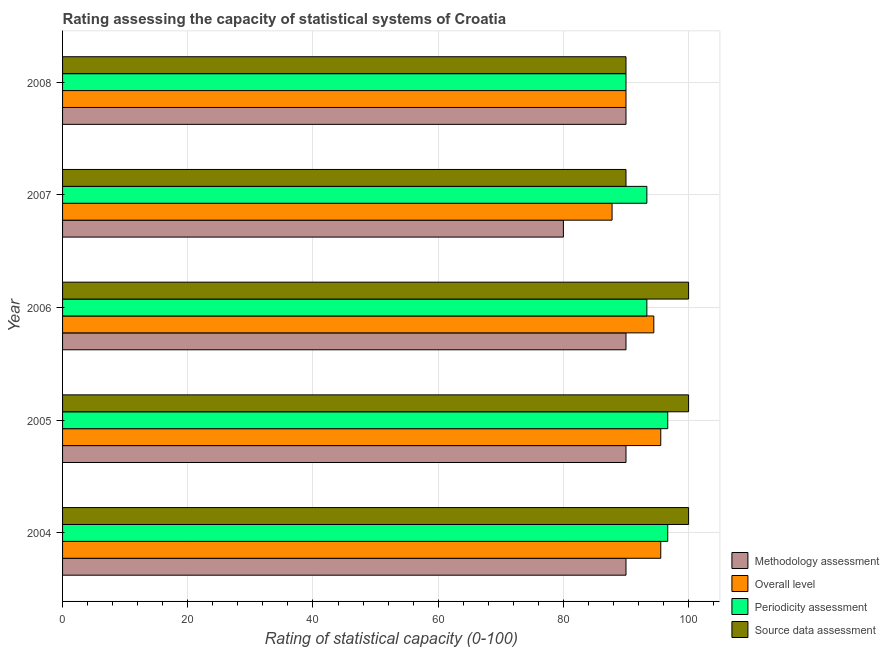How many different coloured bars are there?
Provide a short and direct response. 4. How many groups of bars are there?
Your answer should be compact. 5. Are the number of bars on each tick of the Y-axis equal?
Provide a succinct answer. Yes. What is the label of the 5th group of bars from the top?
Offer a very short reply. 2004. In how many cases, is the number of bars for a given year not equal to the number of legend labels?
Offer a terse response. 0. What is the methodology assessment rating in 2004?
Your response must be concise. 90. Across all years, what is the maximum periodicity assessment rating?
Make the answer very short. 96.67. Across all years, what is the minimum overall level rating?
Ensure brevity in your answer.  87.78. In which year was the source data assessment rating maximum?
Provide a short and direct response. 2004. In which year was the periodicity assessment rating minimum?
Offer a terse response. 2008. What is the total overall level rating in the graph?
Keep it short and to the point. 463.33. What is the difference between the source data assessment rating in 2005 and that in 2007?
Provide a succinct answer. 10. What is the difference between the periodicity assessment rating in 2005 and the source data assessment rating in 2007?
Make the answer very short. 6.67. What is the average methodology assessment rating per year?
Offer a terse response. 88. In the year 2005, what is the difference between the methodology assessment rating and overall level rating?
Your response must be concise. -5.56. In how many years, is the overall level rating greater than 4 ?
Ensure brevity in your answer.  5. What is the ratio of the source data assessment rating in 2004 to that in 2008?
Your response must be concise. 1.11. Is the periodicity assessment rating in 2004 less than that in 2007?
Your response must be concise. No. What is the difference between the highest and the second highest periodicity assessment rating?
Ensure brevity in your answer.  0. What is the difference between the highest and the lowest source data assessment rating?
Make the answer very short. 10. In how many years, is the source data assessment rating greater than the average source data assessment rating taken over all years?
Your response must be concise. 3. Is it the case that in every year, the sum of the periodicity assessment rating and source data assessment rating is greater than the sum of overall level rating and methodology assessment rating?
Offer a very short reply. Yes. What does the 3rd bar from the top in 2004 represents?
Keep it short and to the point. Overall level. What does the 2nd bar from the bottom in 2007 represents?
Your answer should be compact. Overall level. How many years are there in the graph?
Provide a short and direct response. 5. Are the values on the major ticks of X-axis written in scientific E-notation?
Provide a short and direct response. No. Does the graph contain any zero values?
Your response must be concise. No. How many legend labels are there?
Offer a terse response. 4. What is the title of the graph?
Your answer should be compact. Rating assessing the capacity of statistical systems of Croatia. Does "Manufacturing" appear as one of the legend labels in the graph?
Make the answer very short. No. What is the label or title of the X-axis?
Your answer should be very brief. Rating of statistical capacity (0-100). What is the Rating of statistical capacity (0-100) of Methodology assessment in 2004?
Your response must be concise. 90. What is the Rating of statistical capacity (0-100) of Overall level in 2004?
Offer a very short reply. 95.56. What is the Rating of statistical capacity (0-100) in Periodicity assessment in 2004?
Make the answer very short. 96.67. What is the Rating of statistical capacity (0-100) in Source data assessment in 2004?
Provide a short and direct response. 100. What is the Rating of statistical capacity (0-100) of Methodology assessment in 2005?
Offer a very short reply. 90. What is the Rating of statistical capacity (0-100) in Overall level in 2005?
Keep it short and to the point. 95.56. What is the Rating of statistical capacity (0-100) of Periodicity assessment in 2005?
Offer a terse response. 96.67. What is the Rating of statistical capacity (0-100) of Source data assessment in 2005?
Make the answer very short. 100. What is the Rating of statistical capacity (0-100) of Overall level in 2006?
Ensure brevity in your answer.  94.44. What is the Rating of statistical capacity (0-100) of Periodicity assessment in 2006?
Your answer should be compact. 93.33. What is the Rating of statistical capacity (0-100) in Methodology assessment in 2007?
Your answer should be compact. 80. What is the Rating of statistical capacity (0-100) in Overall level in 2007?
Your answer should be compact. 87.78. What is the Rating of statistical capacity (0-100) in Periodicity assessment in 2007?
Keep it short and to the point. 93.33. What is the Rating of statistical capacity (0-100) of Source data assessment in 2007?
Ensure brevity in your answer.  90. What is the Rating of statistical capacity (0-100) in Source data assessment in 2008?
Your response must be concise. 90. Across all years, what is the maximum Rating of statistical capacity (0-100) of Methodology assessment?
Your response must be concise. 90. Across all years, what is the maximum Rating of statistical capacity (0-100) in Overall level?
Provide a short and direct response. 95.56. Across all years, what is the maximum Rating of statistical capacity (0-100) in Periodicity assessment?
Your answer should be compact. 96.67. Across all years, what is the maximum Rating of statistical capacity (0-100) of Source data assessment?
Your answer should be very brief. 100. Across all years, what is the minimum Rating of statistical capacity (0-100) in Methodology assessment?
Keep it short and to the point. 80. Across all years, what is the minimum Rating of statistical capacity (0-100) in Overall level?
Provide a short and direct response. 87.78. Across all years, what is the minimum Rating of statistical capacity (0-100) of Source data assessment?
Offer a very short reply. 90. What is the total Rating of statistical capacity (0-100) in Methodology assessment in the graph?
Your answer should be compact. 440. What is the total Rating of statistical capacity (0-100) of Overall level in the graph?
Give a very brief answer. 463.33. What is the total Rating of statistical capacity (0-100) in Periodicity assessment in the graph?
Provide a short and direct response. 470. What is the total Rating of statistical capacity (0-100) in Source data assessment in the graph?
Offer a terse response. 480. What is the difference between the Rating of statistical capacity (0-100) in Periodicity assessment in 2004 and that in 2005?
Make the answer very short. 0. What is the difference between the Rating of statistical capacity (0-100) in Source data assessment in 2004 and that in 2005?
Keep it short and to the point. 0. What is the difference between the Rating of statistical capacity (0-100) of Methodology assessment in 2004 and that in 2006?
Your answer should be very brief. 0. What is the difference between the Rating of statistical capacity (0-100) in Overall level in 2004 and that in 2006?
Give a very brief answer. 1.11. What is the difference between the Rating of statistical capacity (0-100) of Periodicity assessment in 2004 and that in 2006?
Your answer should be compact. 3.33. What is the difference between the Rating of statistical capacity (0-100) in Overall level in 2004 and that in 2007?
Offer a terse response. 7.78. What is the difference between the Rating of statistical capacity (0-100) in Periodicity assessment in 2004 and that in 2007?
Ensure brevity in your answer.  3.33. What is the difference between the Rating of statistical capacity (0-100) in Methodology assessment in 2004 and that in 2008?
Your response must be concise. 0. What is the difference between the Rating of statistical capacity (0-100) of Overall level in 2004 and that in 2008?
Provide a short and direct response. 5.56. What is the difference between the Rating of statistical capacity (0-100) in Periodicity assessment in 2004 and that in 2008?
Your answer should be compact. 6.67. What is the difference between the Rating of statistical capacity (0-100) of Methodology assessment in 2005 and that in 2006?
Provide a succinct answer. 0. What is the difference between the Rating of statistical capacity (0-100) in Overall level in 2005 and that in 2006?
Offer a terse response. 1.11. What is the difference between the Rating of statistical capacity (0-100) of Periodicity assessment in 2005 and that in 2006?
Provide a succinct answer. 3.33. What is the difference between the Rating of statistical capacity (0-100) of Overall level in 2005 and that in 2007?
Your answer should be very brief. 7.78. What is the difference between the Rating of statistical capacity (0-100) of Source data assessment in 2005 and that in 2007?
Ensure brevity in your answer.  10. What is the difference between the Rating of statistical capacity (0-100) in Methodology assessment in 2005 and that in 2008?
Your answer should be very brief. 0. What is the difference between the Rating of statistical capacity (0-100) of Overall level in 2005 and that in 2008?
Ensure brevity in your answer.  5.56. What is the difference between the Rating of statistical capacity (0-100) of Periodicity assessment in 2005 and that in 2008?
Give a very brief answer. 6.67. What is the difference between the Rating of statistical capacity (0-100) in Source data assessment in 2005 and that in 2008?
Ensure brevity in your answer.  10. What is the difference between the Rating of statistical capacity (0-100) of Overall level in 2006 and that in 2008?
Offer a very short reply. 4.44. What is the difference between the Rating of statistical capacity (0-100) of Periodicity assessment in 2006 and that in 2008?
Your answer should be compact. 3.33. What is the difference between the Rating of statistical capacity (0-100) of Overall level in 2007 and that in 2008?
Your response must be concise. -2.22. What is the difference between the Rating of statistical capacity (0-100) in Methodology assessment in 2004 and the Rating of statistical capacity (0-100) in Overall level in 2005?
Your answer should be very brief. -5.56. What is the difference between the Rating of statistical capacity (0-100) of Methodology assessment in 2004 and the Rating of statistical capacity (0-100) of Periodicity assessment in 2005?
Keep it short and to the point. -6.67. What is the difference between the Rating of statistical capacity (0-100) in Methodology assessment in 2004 and the Rating of statistical capacity (0-100) in Source data assessment in 2005?
Ensure brevity in your answer.  -10. What is the difference between the Rating of statistical capacity (0-100) in Overall level in 2004 and the Rating of statistical capacity (0-100) in Periodicity assessment in 2005?
Ensure brevity in your answer.  -1.11. What is the difference between the Rating of statistical capacity (0-100) of Overall level in 2004 and the Rating of statistical capacity (0-100) of Source data assessment in 2005?
Your answer should be very brief. -4.44. What is the difference between the Rating of statistical capacity (0-100) in Periodicity assessment in 2004 and the Rating of statistical capacity (0-100) in Source data assessment in 2005?
Make the answer very short. -3.33. What is the difference between the Rating of statistical capacity (0-100) of Methodology assessment in 2004 and the Rating of statistical capacity (0-100) of Overall level in 2006?
Keep it short and to the point. -4.44. What is the difference between the Rating of statistical capacity (0-100) in Methodology assessment in 2004 and the Rating of statistical capacity (0-100) in Source data assessment in 2006?
Your answer should be very brief. -10. What is the difference between the Rating of statistical capacity (0-100) in Overall level in 2004 and the Rating of statistical capacity (0-100) in Periodicity assessment in 2006?
Make the answer very short. 2.22. What is the difference between the Rating of statistical capacity (0-100) in Overall level in 2004 and the Rating of statistical capacity (0-100) in Source data assessment in 2006?
Keep it short and to the point. -4.44. What is the difference between the Rating of statistical capacity (0-100) of Methodology assessment in 2004 and the Rating of statistical capacity (0-100) of Overall level in 2007?
Provide a short and direct response. 2.22. What is the difference between the Rating of statistical capacity (0-100) in Methodology assessment in 2004 and the Rating of statistical capacity (0-100) in Periodicity assessment in 2007?
Your response must be concise. -3.33. What is the difference between the Rating of statistical capacity (0-100) of Overall level in 2004 and the Rating of statistical capacity (0-100) of Periodicity assessment in 2007?
Offer a very short reply. 2.22. What is the difference between the Rating of statistical capacity (0-100) in Overall level in 2004 and the Rating of statistical capacity (0-100) in Source data assessment in 2007?
Offer a very short reply. 5.56. What is the difference between the Rating of statistical capacity (0-100) of Periodicity assessment in 2004 and the Rating of statistical capacity (0-100) of Source data assessment in 2007?
Provide a short and direct response. 6.67. What is the difference between the Rating of statistical capacity (0-100) of Methodology assessment in 2004 and the Rating of statistical capacity (0-100) of Overall level in 2008?
Provide a succinct answer. 0. What is the difference between the Rating of statistical capacity (0-100) in Methodology assessment in 2004 and the Rating of statistical capacity (0-100) in Periodicity assessment in 2008?
Offer a terse response. 0. What is the difference between the Rating of statistical capacity (0-100) in Overall level in 2004 and the Rating of statistical capacity (0-100) in Periodicity assessment in 2008?
Ensure brevity in your answer.  5.56. What is the difference between the Rating of statistical capacity (0-100) in Overall level in 2004 and the Rating of statistical capacity (0-100) in Source data assessment in 2008?
Make the answer very short. 5.56. What is the difference between the Rating of statistical capacity (0-100) of Methodology assessment in 2005 and the Rating of statistical capacity (0-100) of Overall level in 2006?
Offer a very short reply. -4.44. What is the difference between the Rating of statistical capacity (0-100) in Methodology assessment in 2005 and the Rating of statistical capacity (0-100) in Source data assessment in 2006?
Keep it short and to the point. -10. What is the difference between the Rating of statistical capacity (0-100) in Overall level in 2005 and the Rating of statistical capacity (0-100) in Periodicity assessment in 2006?
Provide a succinct answer. 2.22. What is the difference between the Rating of statistical capacity (0-100) in Overall level in 2005 and the Rating of statistical capacity (0-100) in Source data assessment in 2006?
Your answer should be compact. -4.44. What is the difference between the Rating of statistical capacity (0-100) of Periodicity assessment in 2005 and the Rating of statistical capacity (0-100) of Source data assessment in 2006?
Offer a very short reply. -3.33. What is the difference between the Rating of statistical capacity (0-100) of Methodology assessment in 2005 and the Rating of statistical capacity (0-100) of Overall level in 2007?
Offer a terse response. 2.22. What is the difference between the Rating of statistical capacity (0-100) in Methodology assessment in 2005 and the Rating of statistical capacity (0-100) in Source data assessment in 2007?
Make the answer very short. 0. What is the difference between the Rating of statistical capacity (0-100) in Overall level in 2005 and the Rating of statistical capacity (0-100) in Periodicity assessment in 2007?
Ensure brevity in your answer.  2.22. What is the difference between the Rating of statistical capacity (0-100) of Overall level in 2005 and the Rating of statistical capacity (0-100) of Source data assessment in 2007?
Offer a terse response. 5.56. What is the difference between the Rating of statistical capacity (0-100) of Methodology assessment in 2005 and the Rating of statistical capacity (0-100) of Periodicity assessment in 2008?
Keep it short and to the point. 0. What is the difference between the Rating of statistical capacity (0-100) of Overall level in 2005 and the Rating of statistical capacity (0-100) of Periodicity assessment in 2008?
Make the answer very short. 5.56. What is the difference between the Rating of statistical capacity (0-100) of Overall level in 2005 and the Rating of statistical capacity (0-100) of Source data assessment in 2008?
Offer a terse response. 5.56. What is the difference between the Rating of statistical capacity (0-100) in Periodicity assessment in 2005 and the Rating of statistical capacity (0-100) in Source data assessment in 2008?
Your answer should be very brief. 6.67. What is the difference between the Rating of statistical capacity (0-100) in Methodology assessment in 2006 and the Rating of statistical capacity (0-100) in Overall level in 2007?
Ensure brevity in your answer.  2.22. What is the difference between the Rating of statistical capacity (0-100) in Methodology assessment in 2006 and the Rating of statistical capacity (0-100) in Source data assessment in 2007?
Your response must be concise. 0. What is the difference between the Rating of statistical capacity (0-100) in Overall level in 2006 and the Rating of statistical capacity (0-100) in Periodicity assessment in 2007?
Offer a terse response. 1.11. What is the difference between the Rating of statistical capacity (0-100) of Overall level in 2006 and the Rating of statistical capacity (0-100) of Source data assessment in 2007?
Ensure brevity in your answer.  4.44. What is the difference between the Rating of statistical capacity (0-100) in Methodology assessment in 2006 and the Rating of statistical capacity (0-100) in Overall level in 2008?
Your response must be concise. 0. What is the difference between the Rating of statistical capacity (0-100) in Overall level in 2006 and the Rating of statistical capacity (0-100) in Periodicity assessment in 2008?
Keep it short and to the point. 4.44. What is the difference between the Rating of statistical capacity (0-100) in Overall level in 2006 and the Rating of statistical capacity (0-100) in Source data assessment in 2008?
Your answer should be compact. 4.44. What is the difference between the Rating of statistical capacity (0-100) in Methodology assessment in 2007 and the Rating of statistical capacity (0-100) in Periodicity assessment in 2008?
Give a very brief answer. -10. What is the difference between the Rating of statistical capacity (0-100) in Overall level in 2007 and the Rating of statistical capacity (0-100) in Periodicity assessment in 2008?
Offer a terse response. -2.22. What is the difference between the Rating of statistical capacity (0-100) in Overall level in 2007 and the Rating of statistical capacity (0-100) in Source data assessment in 2008?
Provide a succinct answer. -2.22. What is the difference between the Rating of statistical capacity (0-100) in Periodicity assessment in 2007 and the Rating of statistical capacity (0-100) in Source data assessment in 2008?
Keep it short and to the point. 3.33. What is the average Rating of statistical capacity (0-100) in Methodology assessment per year?
Make the answer very short. 88. What is the average Rating of statistical capacity (0-100) in Overall level per year?
Your answer should be very brief. 92.67. What is the average Rating of statistical capacity (0-100) of Periodicity assessment per year?
Offer a very short reply. 94. What is the average Rating of statistical capacity (0-100) in Source data assessment per year?
Your answer should be compact. 96. In the year 2004, what is the difference between the Rating of statistical capacity (0-100) of Methodology assessment and Rating of statistical capacity (0-100) of Overall level?
Offer a very short reply. -5.56. In the year 2004, what is the difference between the Rating of statistical capacity (0-100) of Methodology assessment and Rating of statistical capacity (0-100) of Periodicity assessment?
Your answer should be compact. -6.67. In the year 2004, what is the difference between the Rating of statistical capacity (0-100) of Methodology assessment and Rating of statistical capacity (0-100) of Source data assessment?
Provide a succinct answer. -10. In the year 2004, what is the difference between the Rating of statistical capacity (0-100) of Overall level and Rating of statistical capacity (0-100) of Periodicity assessment?
Your response must be concise. -1.11. In the year 2004, what is the difference between the Rating of statistical capacity (0-100) of Overall level and Rating of statistical capacity (0-100) of Source data assessment?
Provide a succinct answer. -4.44. In the year 2004, what is the difference between the Rating of statistical capacity (0-100) in Periodicity assessment and Rating of statistical capacity (0-100) in Source data assessment?
Provide a succinct answer. -3.33. In the year 2005, what is the difference between the Rating of statistical capacity (0-100) of Methodology assessment and Rating of statistical capacity (0-100) of Overall level?
Provide a short and direct response. -5.56. In the year 2005, what is the difference between the Rating of statistical capacity (0-100) in Methodology assessment and Rating of statistical capacity (0-100) in Periodicity assessment?
Make the answer very short. -6.67. In the year 2005, what is the difference between the Rating of statistical capacity (0-100) of Methodology assessment and Rating of statistical capacity (0-100) of Source data assessment?
Give a very brief answer. -10. In the year 2005, what is the difference between the Rating of statistical capacity (0-100) of Overall level and Rating of statistical capacity (0-100) of Periodicity assessment?
Keep it short and to the point. -1.11. In the year 2005, what is the difference between the Rating of statistical capacity (0-100) in Overall level and Rating of statistical capacity (0-100) in Source data assessment?
Keep it short and to the point. -4.44. In the year 2006, what is the difference between the Rating of statistical capacity (0-100) of Methodology assessment and Rating of statistical capacity (0-100) of Overall level?
Give a very brief answer. -4.44. In the year 2006, what is the difference between the Rating of statistical capacity (0-100) of Methodology assessment and Rating of statistical capacity (0-100) of Periodicity assessment?
Give a very brief answer. -3.33. In the year 2006, what is the difference between the Rating of statistical capacity (0-100) of Overall level and Rating of statistical capacity (0-100) of Source data assessment?
Provide a short and direct response. -5.56. In the year 2006, what is the difference between the Rating of statistical capacity (0-100) of Periodicity assessment and Rating of statistical capacity (0-100) of Source data assessment?
Ensure brevity in your answer.  -6.67. In the year 2007, what is the difference between the Rating of statistical capacity (0-100) in Methodology assessment and Rating of statistical capacity (0-100) in Overall level?
Provide a short and direct response. -7.78. In the year 2007, what is the difference between the Rating of statistical capacity (0-100) in Methodology assessment and Rating of statistical capacity (0-100) in Periodicity assessment?
Offer a very short reply. -13.33. In the year 2007, what is the difference between the Rating of statistical capacity (0-100) in Overall level and Rating of statistical capacity (0-100) in Periodicity assessment?
Provide a short and direct response. -5.56. In the year 2007, what is the difference between the Rating of statistical capacity (0-100) of Overall level and Rating of statistical capacity (0-100) of Source data assessment?
Your response must be concise. -2.22. What is the ratio of the Rating of statistical capacity (0-100) in Methodology assessment in 2004 to that in 2005?
Offer a terse response. 1. What is the ratio of the Rating of statistical capacity (0-100) in Overall level in 2004 to that in 2006?
Your answer should be very brief. 1.01. What is the ratio of the Rating of statistical capacity (0-100) in Periodicity assessment in 2004 to that in 2006?
Ensure brevity in your answer.  1.04. What is the ratio of the Rating of statistical capacity (0-100) of Source data assessment in 2004 to that in 2006?
Your answer should be very brief. 1. What is the ratio of the Rating of statistical capacity (0-100) in Methodology assessment in 2004 to that in 2007?
Provide a short and direct response. 1.12. What is the ratio of the Rating of statistical capacity (0-100) in Overall level in 2004 to that in 2007?
Your answer should be very brief. 1.09. What is the ratio of the Rating of statistical capacity (0-100) in Periodicity assessment in 2004 to that in 2007?
Offer a terse response. 1.04. What is the ratio of the Rating of statistical capacity (0-100) of Overall level in 2004 to that in 2008?
Keep it short and to the point. 1.06. What is the ratio of the Rating of statistical capacity (0-100) of Periodicity assessment in 2004 to that in 2008?
Make the answer very short. 1.07. What is the ratio of the Rating of statistical capacity (0-100) of Source data assessment in 2004 to that in 2008?
Your answer should be compact. 1.11. What is the ratio of the Rating of statistical capacity (0-100) in Overall level in 2005 to that in 2006?
Your answer should be compact. 1.01. What is the ratio of the Rating of statistical capacity (0-100) of Periodicity assessment in 2005 to that in 2006?
Provide a succinct answer. 1.04. What is the ratio of the Rating of statistical capacity (0-100) of Source data assessment in 2005 to that in 2006?
Your response must be concise. 1. What is the ratio of the Rating of statistical capacity (0-100) in Methodology assessment in 2005 to that in 2007?
Make the answer very short. 1.12. What is the ratio of the Rating of statistical capacity (0-100) of Overall level in 2005 to that in 2007?
Provide a succinct answer. 1.09. What is the ratio of the Rating of statistical capacity (0-100) in Periodicity assessment in 2005 to that in 2007?
Keep it short and to the point. 1.04. What is the ratio of the Rating of statistical capacity (0-100) of Source data assessment in 2005 to that in 2007?
Your response must be concise. 1.11. What is the ratio of the Rating of statistical capacity (0-100) of Overall level in 2005 to that in 2008?
Offer a very short reply. 1.06. What is the ratio of the Rating of statistical capacity (0-100) in Periodicity assessment in 2005 to that in 2008?
Your answer should be compact. 1.07. What is the ratio of the Rating of statistical capacity (0-100) in Overall level in 2006 to that in 2007?
Offer a very short reply. 1.08. What is the ratio of the Rating of statistical capacity (0-100) of Periodicity assessment in 2006 to that in 2007?
Ensure brevity in your answer.  1. What is the ratio of the Rating of statistical capacity (0-100) in Overall level in 2006 to that in 2008?
Offer a very short reply. 1.05. What is the ratio of the Rating of statistical capacity (0-100) in Source data assessment in 2006 to that in 2008?
Keep it short and to the point. 1.11. What is the ratio of the Rating of statistical capacity (0-100) of Methodology assessment in 2007 to that in 2008?
Provide a short and direct response. 0.89. What is the ratio of the Rating of statistical capacity (0-100) in Overall level in 2007 to that in 2008?
Offer a very short reply. 0.98. What is the ratio of the Rating of statistical capacity (0-100) in Source data assessment in 2007 to that in 2008?
Keep it short and to the point. 1. What is the difference between the highest and the second highest Rating of statistical capacity (0-100) of Methodology assessment?
Offer a very short reply. 0. What is the difference between the highest and the second highest Rating of statistical capacity (0-100) of Periodicity assessment?
Offer a terse response. 0. What is the difference between the highest and the lowest Rating of statistical capacity (0-100) in Methodology assessment?
Ensure brevity in your answer.  10. What is the difference between the highest and the lowest Rating of statistical capacity (0-100) of Overall level?
Your answer should be very brief. 7.78. What is the difference between the highest and the lowest Rating of statistical capacity (0-100) in Periodicity assessment?
Give a very brief answer. 6.67. What is the difference between the highest and the lowest Rating of statistical capacity (0-100) of Source data assessment?
Provide a short and direct response. 10. 